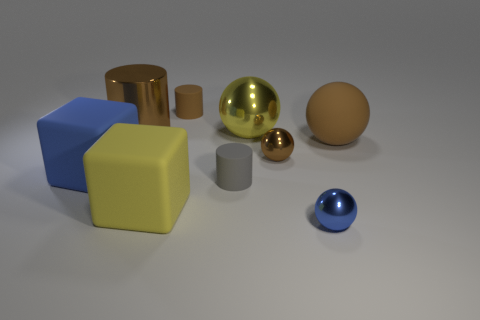How many other things are the same color as the large matte ball?
Your answer should be very brief. 3. The big matte sphere is what color?
Provide a short and direct response. Brown. There is a cylinder that is behind the tiny brown metallic sphere and to the right of the large metal cylinder; how big is it?
Provide a succinct answer. Small. What number of objects are big blue blocks that are left of the large brown matte object or large gray shiny cylinders?
Provide a succinct answer. 1. What shape is the blue thing that is the same material as the large brown sphere?
Offer a very short reply. Cube. What shape is the tiny blue shiny thing?
Give a very brief answer. Sphere. There is a tiny object that is both behind the yellow matte thing and to the right of the tiny gray cylinder; what color is it?
Offer a terse response. Brown. There is a brown metal object that is the same size as the yellow cube; what shape is it?
Give a very brief answer. Cylinder. Is there a large brown thing of the same shape as the small brown matte object?
Keep it short and to the point. Yes. Do the large cylinder and the small cylinder in front of the big brown metal object have the same material?
Your answer should be very brief. No. 